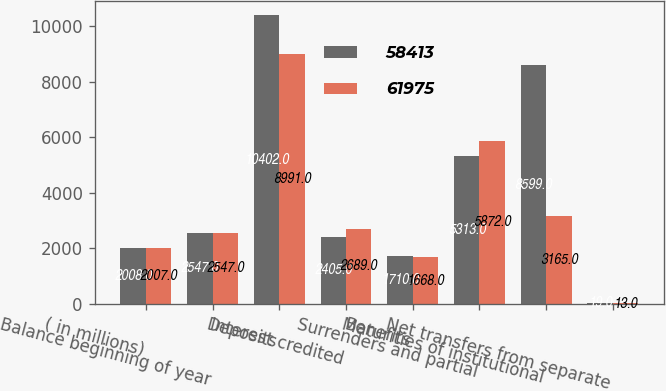Convert chart. <chart><loc_0><loc_0><loc_500><loc_500><stacked_bar_chart><ecel><fcel>( in millions)<fcel>Balance beginning of year<fcel>Deposits<fcel>Interest credited<fcel>Benefits<fcel>Surrenders and partial<fcel>Maturities of institutional<fcel>Net transfers from separate<nl><fcel>58413<fcel>2008<fcel>2547<fcel>10402<fcel>2405<fcel>1710<fcel>5313<fcel>8599<fcel>19<nl><fcel>61975<fcel>2007<fcel>2547<fcel>8991<fcel>2689<fcel>1668<fcel>5872<fcel>3165<fcel>13<nl></chart> 